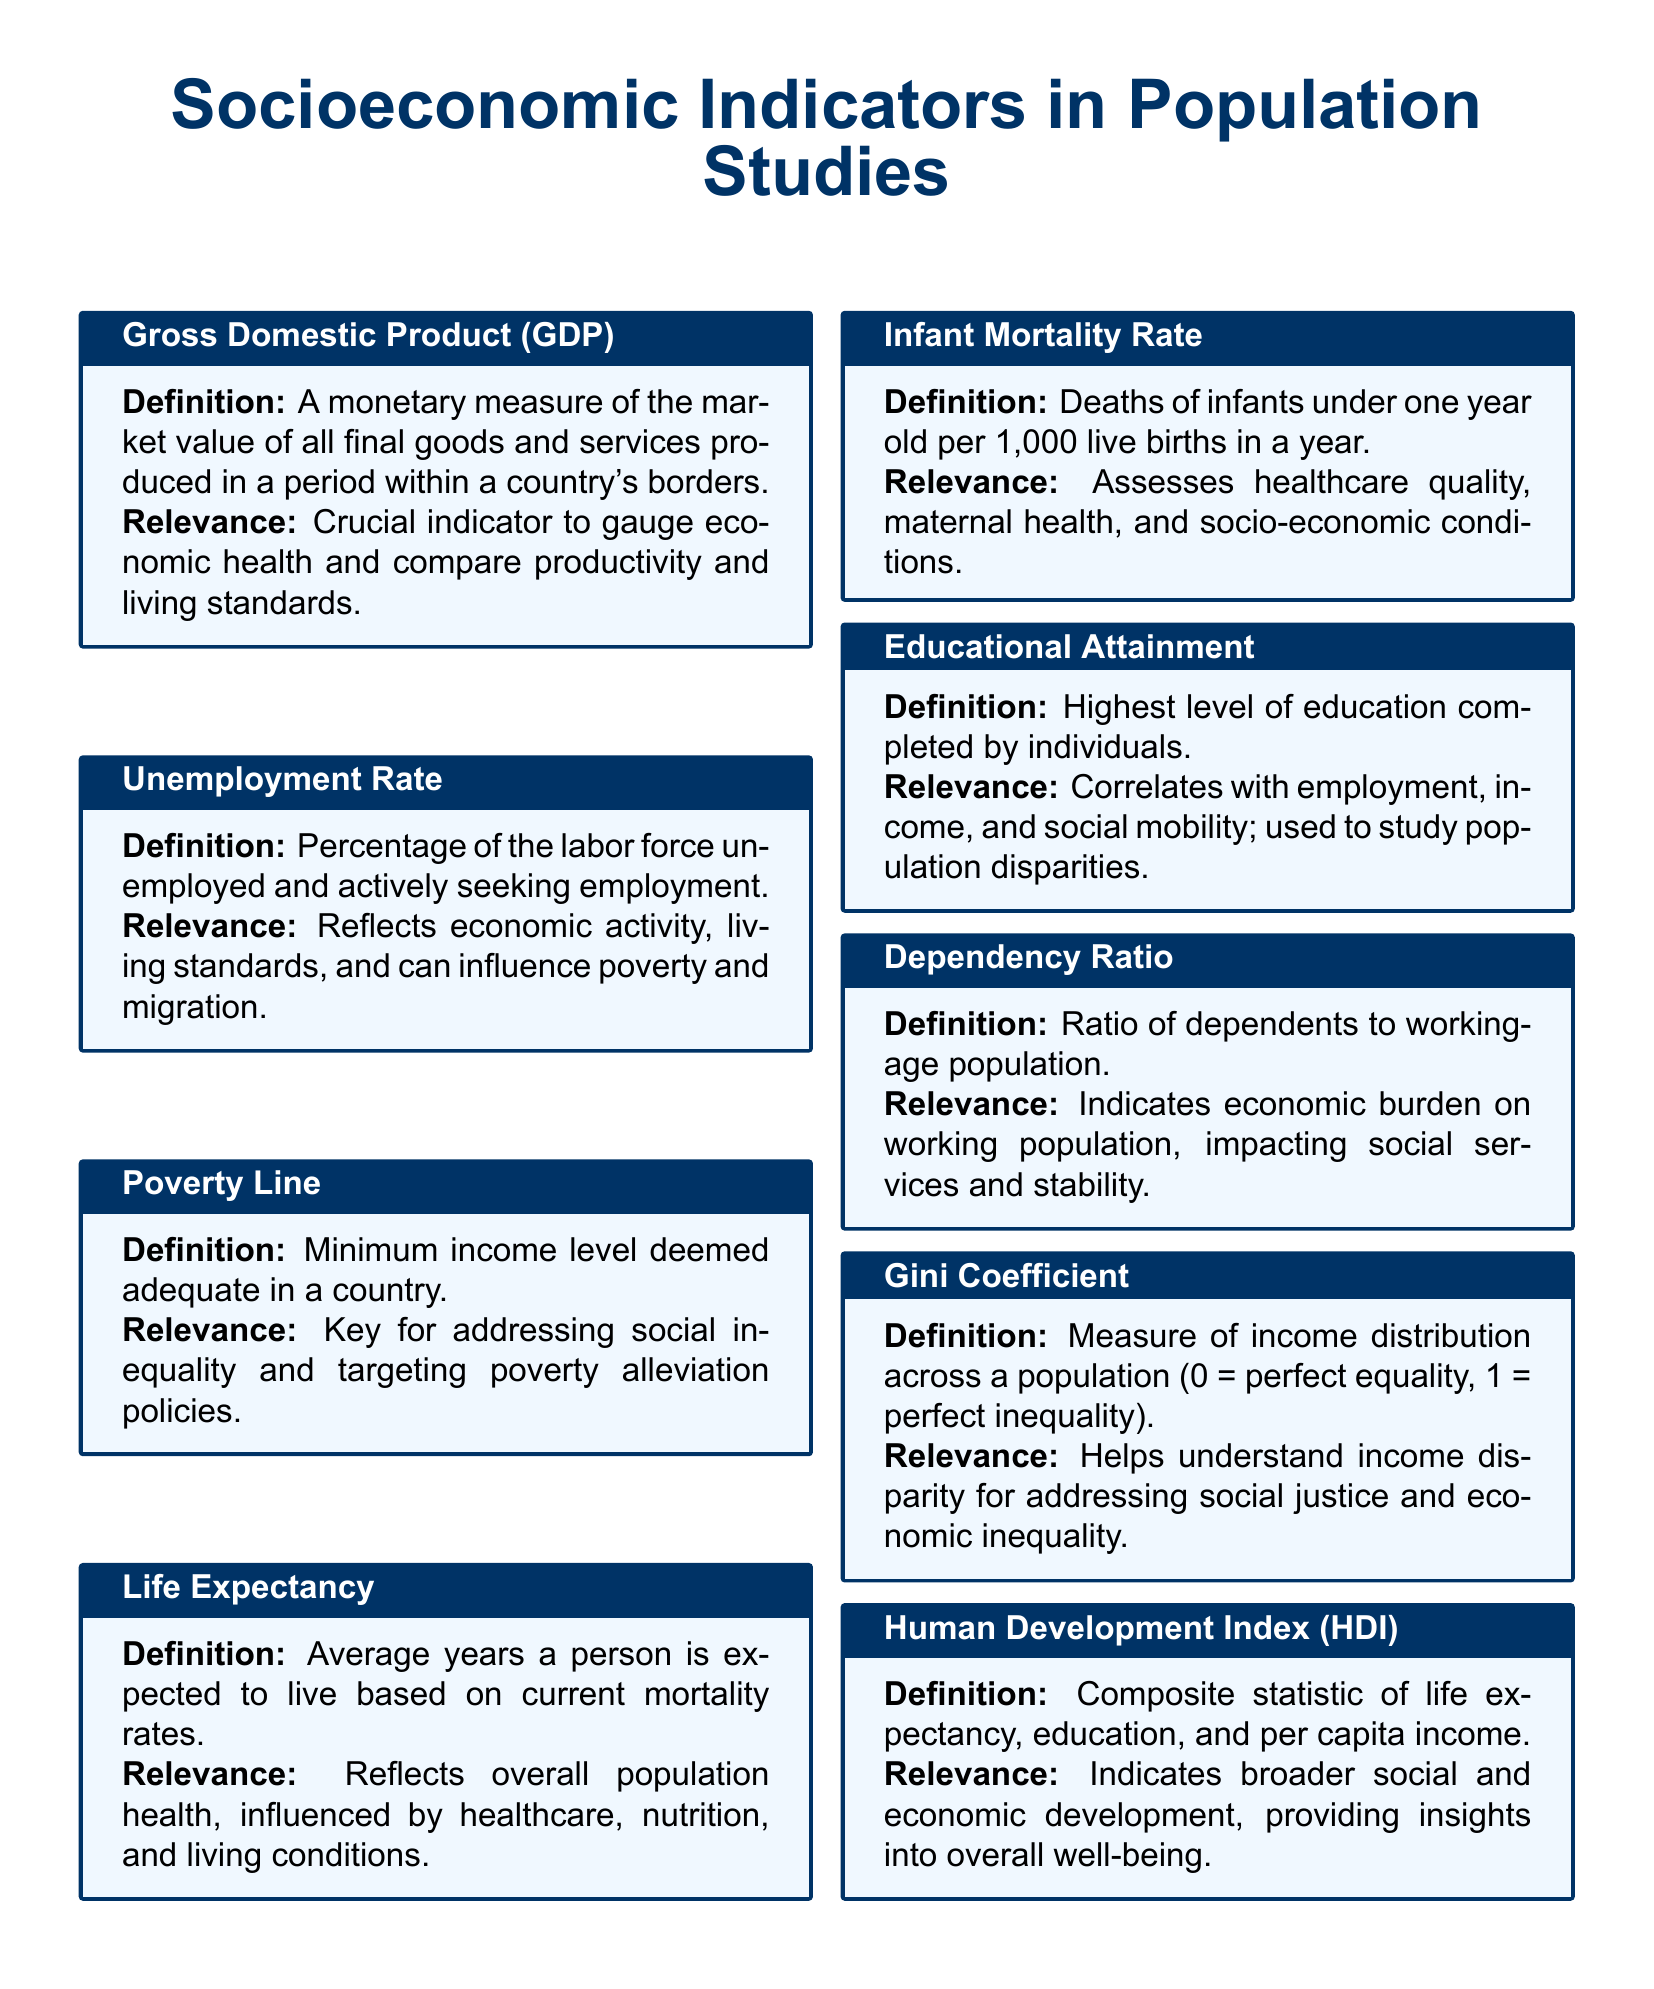What is the definition of Gross Domestic Product (GDP)? The definition of GDP is provided in the section describing it in the document.
Answer: A monetary measure of the market value of all final goods and services produced in a period within a country's borders What does the Unemployment Rate reflect? The relevance section for the Unemployment Rate explains its significance in understanding economic activity.
Answer: Reflects economic activity, living standards, and can influence poverty and migration What minimum income level is referred to as the Poverty Line? The document states that the Poverty Line is defined as a minimum income level in a country.
Answer: Minimum income level deemed adequate in a country What is the average years a person is expected to live according to Life Expectancy? The Life Expectancy section explains its definition based on current mortality rates.
Answer: Average years a person is expected to live based on current mortality rates How does Educational Attainment correlate with other factors? The relevance of Educational Attainment discusses its correlation with employment and income.
Answer: Correlates with employment, income, and social mobility What is the significance of the Gini Coefficient? The relevance section for the Gini Coefficient indicates its role in understanding income disparity.
Answer: Helps understand income disparity for addressing social justice and economic inequality What does the Human Development Index (HDI) combine? The definition of HDI includes information on the components considered within it.
Answer: Composite statistic of life expectancy, education, and per capita income What does a high Dependency Ratio indicate? The relevance of the Dependency Ratio mentions its implications on economic burden.
Answer: Indicates economic burden on working population What is the perfect equality value of the Gini Coefficient? The document specifies the range of the Gini Coefficient, including the perfect equality value.
Answer: 0 